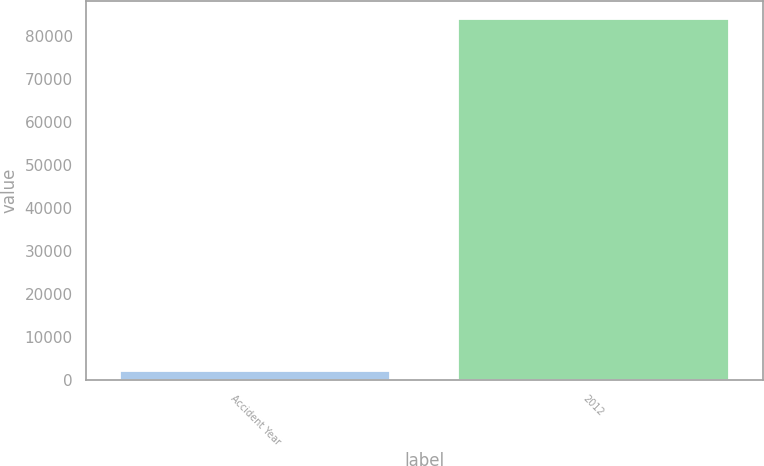Convert chart. <chart><loc_0><loc_0><loc_500><loc_500><bar_chart><fcel>Accident Year<fcel>2012<nl><fcel>2014<fcel>83919<nl></chart> 